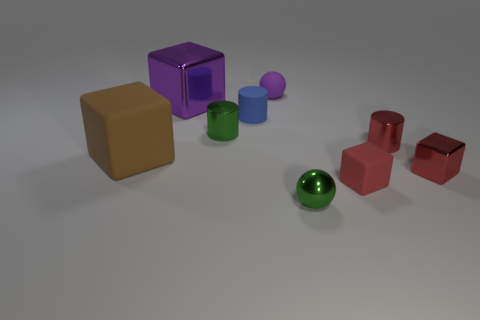Subtract all blue cubes. Subtract all yellow balls. How many cubes are left? 4 Subtract all balls. How many objects are left? 7 Add 1 purple balls. How many objects exist? 10 Add 1 small metal things. How many small metal things exist? 5 Subtract 0 cyan cylinders. How many objects are left? 9 Subtract all green cylinders. Subtract all tiny blue cylinders. How many objects are left? 7 Add 3 small green cylinders. How many small green cylinders are left? 4 